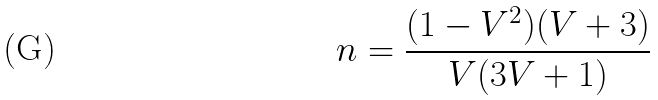<formula> <loc_0><loc_0><loc_500><loc_500>n = \frac { ( 1 - V ^ { 2 } ) ( V + 3 ) } { V ( 3 V + 1 ) }</formula> 